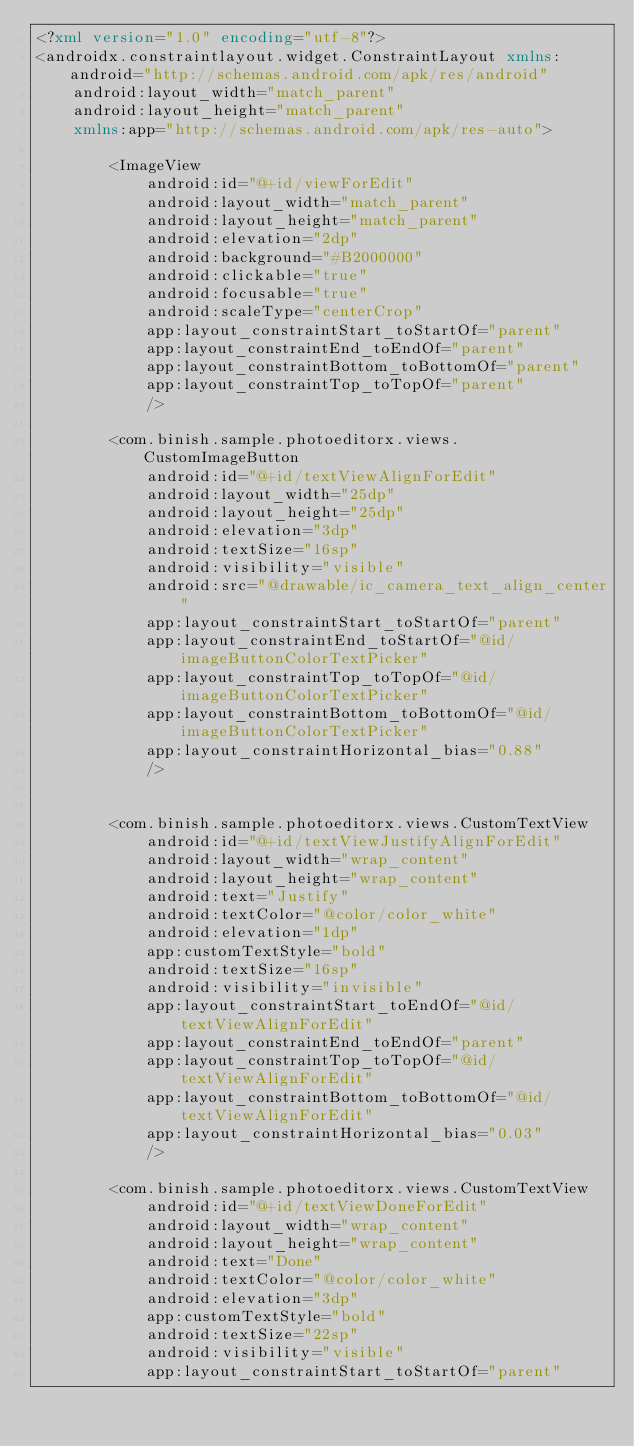Convert code to text. <code><loc_0><loc_0><loc_500><loc_500><_XML_><?xml version="1.0" encoding="utf-8"?>
<androidx.constraintlayout.widget.ConstraintLayout xmlns:android="http://schemas.android.com/apk/res/android"
    android:layout_width="match_parent"
    android:layout_height="match_parent"
    xmlns:app="http://schemas.android.com/apk/res-auto">

        <ImageView
            android:id="@+id/viewForEdit"
            android:layout_width="match_parent"
            android:layout_height="match_parent"
            android:elevation="2dp"
            android:background="#B2000000"
            android:clickable="true"
            android:focusable="true"
            android:scaleType="centerCrop"
            app:layout_constraintStart_toStartOf="parent"
            app:layout_constraintEnd_toEndOf="parent"
            app:layout_constraintBottom_toBottomOf="parent"
            app:layout_constraintTop_toTopOf="parent"
            />

        <com.binish.sample.photoeditorx.views.CustomImageButton
            android:id="@+id/textViewAlignForEdit"
            android:layout_width="25dp"
            android:layout_height="25dp"
            android:elevation="3dp"
            android:textSize="16sp"
            android:visibility="visible"
            android:src="@drawable/ic_camera_text_align_center"
            app:layout_constraintStart_toStartOf="parent"
            app:layout_constraintEnd_toStartOf="@id/imageButtonColorTextPicker"
            app:layout_constraintTop_toTopOf="@id/imageButtonColorTextPicker"
            app:layout_constraintBottom_toBottomOf="@id/imageButtonColorTextPicker"
            app:layout_constraintHorizontal_bias="0.88"
            />


        <com.binish.sample.photoeditorx.views.CustomTextView
            android:id="@+id/textViewJustifyAlignForEdit"
            android:layout_width="wrap_content"
            android:layout_height="wrap_content"
            android:text="Justify"
            android:textColor="@color/color_white"
            android:elevation="1dp"
            app:customTextStyle="bold"
            android:textSize="16sp"
            android:visibility="invisible"
            app:layout_constraintStart_toEndOf="@id/textViewAlignForEdit"
            app:layout_constraintEnd_toEndOf="parent"
            app:layout_constraintTop_toTopOf="@id/textViewAlignForEdit"
            app:layout_constraintBottom_toBottomOf="@id/textViewAlignForEdit"
            app:layout_constraintHorizontal_bias="0.03"
            />

        <com.binish.sample.photoeditorx.views.CustomTextView
            android:id="@+id/textViewDoneForEdit"
            android:layout_width="wrap_content"
            android:layout_height="wrap_content"
            android:text="Done"
            android:textColor="@color/color_white"
            android:elevation="3dp"
            app:customTextStyle="bold"
            android:textSize="22sp"
            android:visibility="visible"
            app:layout_constraintStart_toStartOf="parent"</code> 